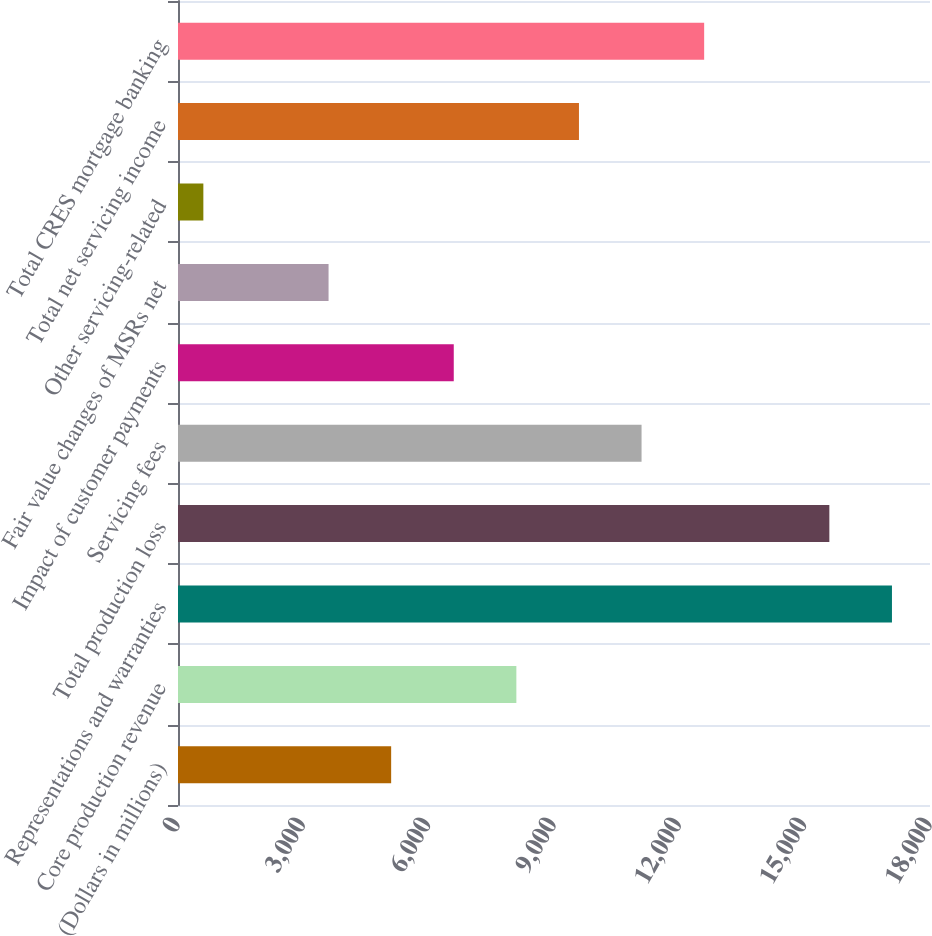Convert chart. <chart><loc_0><loc_0><loc_500><loc_500><bar_chart><fcel>(Dollars in millions)<fcel>Core production revenue<fcel>Representations and warranties<fcel>Total production loss<fcel>Servicing fees<fcel>Impact of customer payments<fcel>Fair value changes of MSRs net<fcel>Other servicing-related<fcel>Total net servicing income<fcel>Total CRES mortgage banking<nl><fcel>5102.2<fcel>8099<fcel>17089.4<fcel>15591<fcel>11095.8<fcel>6600.6<fcel>3603.8<fcel>607<fcel>9597.4<fcel>12594.2<nl></chart> 